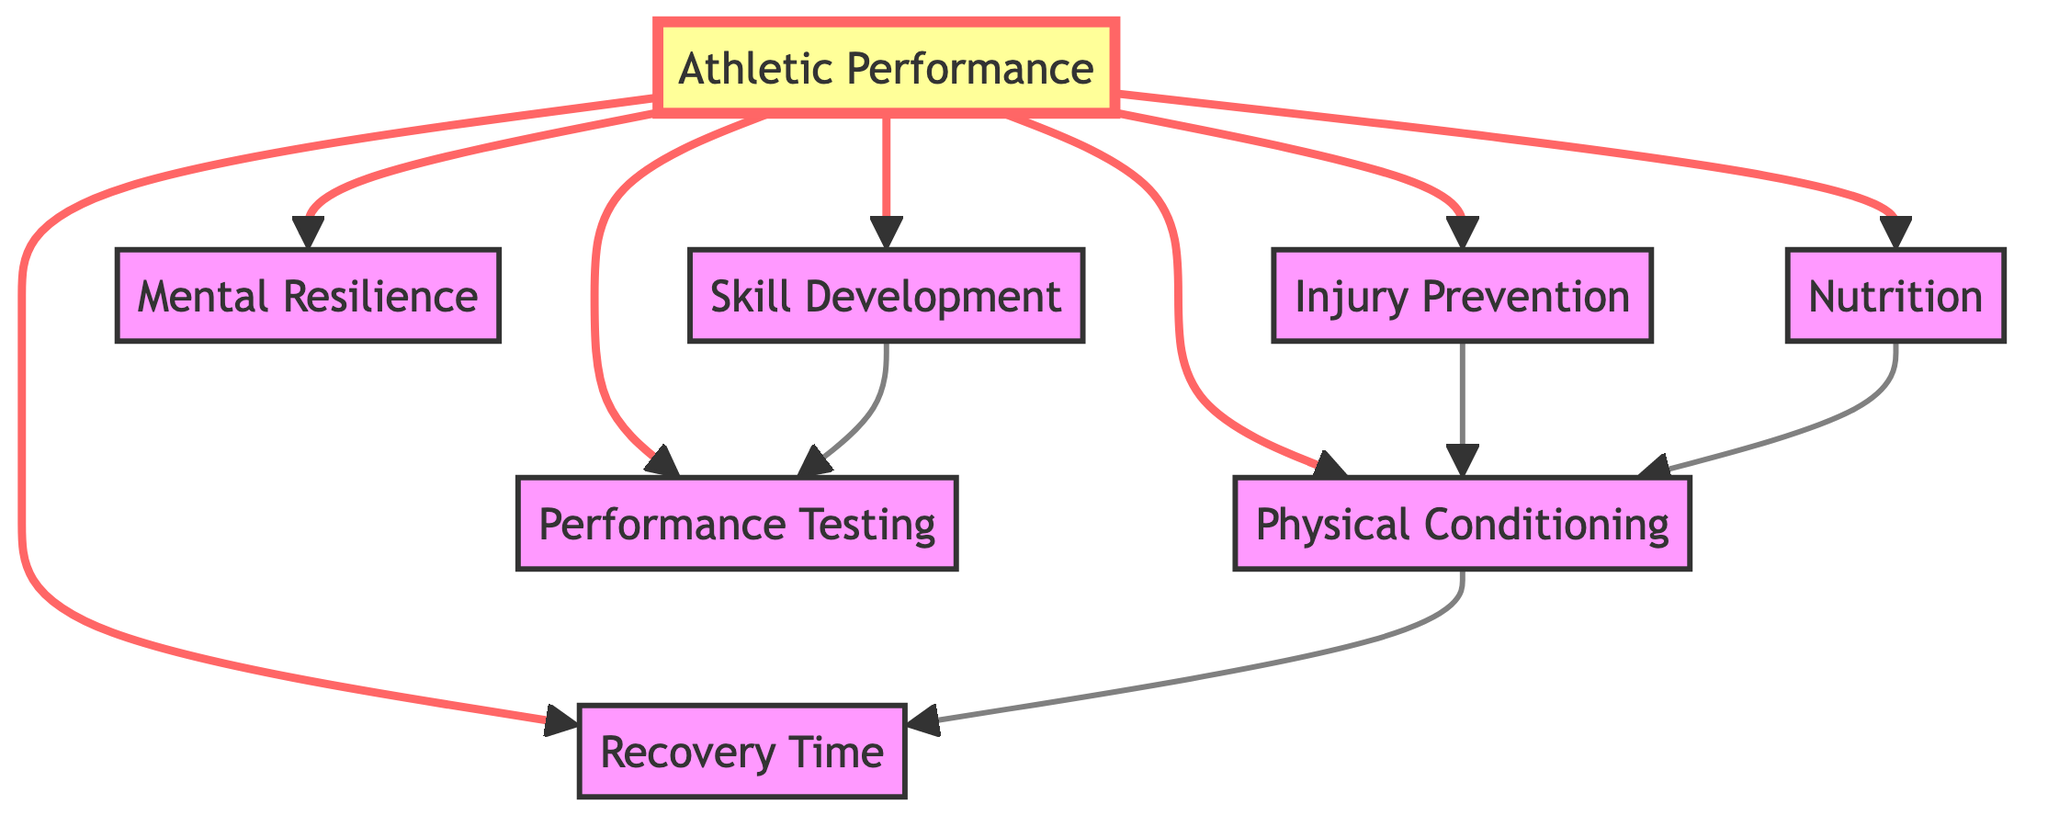What is the central node in the diagram? The central node in the diagram is "Athletic Performance" as all other nodes are connected to it, making it the primary focus of the evaluation metrics.
Answer: Athletic Performance How many nodes are present in the diagram? The diagram contains a total of eight nodes, which are: Athletic Performance, Physical Conditioning, Skill Development, Mental Resilience, Injury Prevention, Recovery Time, Performance Testing, and Nutrition.
Answer: Eight Which nodes are directly connected to "Athletic Performance"? The nodes directly connected to "Athletic Performance" are Physical Conditioning, Skill Development, Mental Resilience, Injury Prevention, Recovery Time, Performance Testing, and Nutrition. This relationship indicates that these aspects contribute directly to athletic performance.
Answer: Physical Conditioning, Skill Development, Mental Resilience, Injury Prevention, Recovery Time, Performance Testing, Nutrition What metric leads to "Recovery Time"? "Physical Conditioning" is the metric that leads to "Recovery Time," as indicated by the directed edge connecting them, suggesting that better physical conditioning can reduce recovery time after training.
Answer: Physical Conditioning Which two nodes influence "Physical Conditioning"? The nodes that influence "Physical Conditioning" are "Injury Prevention" and "Nutrition," as they both have edges leading towards Physical Conditioning, indicating their roles in enhancing it.
Answer: Injury Prevention, Nutrition How many edges are there in the diagram? The diagram consists of eleven directed edges that represent the relationships between the various metrics in athletic performance evaluation.
Answer: Eleven Which metric results from "Skill Development"? The outcome of "Skill Development" is "Performance Testing," based on the direct connection in the diagram, showing that enhancing skill inevitably leads to improved performance testing outcomes.
Answer: Performance Testing Which node does not affect "Mental Resilience"? "Recovery Time" does not affect "Mental Resilience," as there is no direct edge or connection indicating a relationship between these two nodes in the diagram.
Answer: Recovery Time What is the relationship between "Nutrition" and "Recovery Time"? "Nutrition" influences "Physical Conditioning," which in turn impacts "Recovery Time," creating an indirect connection that highlights the cascading effect of nutrition on recovery.
Answer: Indirect relationship through Physical Conditioning 